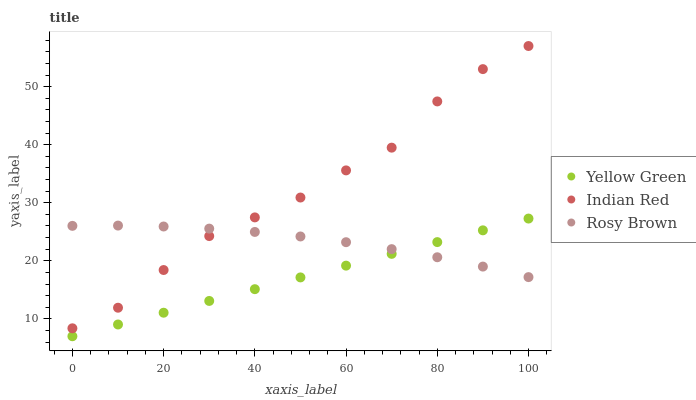Does Yellow Green have the minimum area under the curve?
Answer yes or no. Yes. Does Indian Red have the maximum area under the curve?
Answer yes or no. Yes. Does Indian Red have the minimum area under the curve?
Answer yes or no. No. Does Yellow Green have the maximum area under the curve?
Answer yes or no. No. Is Yellow Green the smoothest?
Answer yes or no. Yes. Is Indian Red the roughest?
Answer yes or no. Yes. Is Indian Red the smoothest?
Answer yes or no. No. Is Yellow Green the roughest?
Answer yes or no. No. Does Yellow Green have the lowest value?
Answer yes or no. Yes. Does Indian Red have the lowest value?
Answer yes or no. No. Does Indian Red have the highest value?
Answer yes or no. Yes. Does Yellow Green have the highest value?
Answer yes or no. No. Is Yellow Green less than Indian Red?
Answer yes or no. Yes. Is Indian Red greater than Yellow Green?
Answer yes or no. Yes. Does Indian Red intersect Rosy Brown?
Answer yes or no. Yes. Is Indian Red less than Rosy Brown?
Answer yes or no. No. Is Indian Red greater than Rosy Brown?
Answer yes or no. No. Does Yellow Green intersect Indian Red?
Answer yes or no. No. 